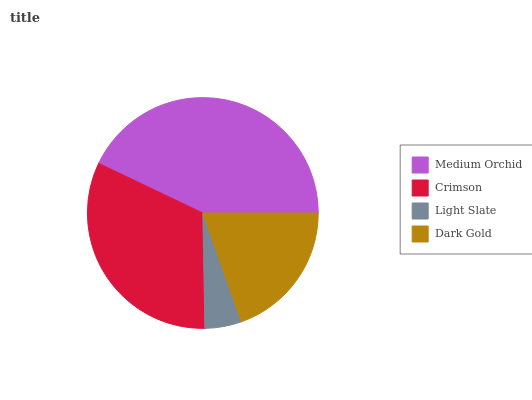Is Light Slate the minimum?
Answer yes or no. Yes. Is Medium Orchid the maximum?
Answer yes or no. Yes. Is Crimson the minimum?
Answer yes or no. No. Is Crimson the maximum?
Answer yes or no. No. Is Medium Orchid greater than Crimson?
Answer yes or no. Yes. Is Crimson less than Medium Orchid?
Answer yes or no. Yes. Is Crimson greater than Medium Orchid?
Answer yes or no. No. Is Medium Orchid less than Crimson?
Answer yes or no. No. Is Crimson the high median?
Answer yes or no. Yes. Is Dark Gold the low median?
Answer yes or no. Yes. Is Dark Gold the high median?
Answer yes or no. No. Is Crimson the low median?
Answer yes or no. No. 